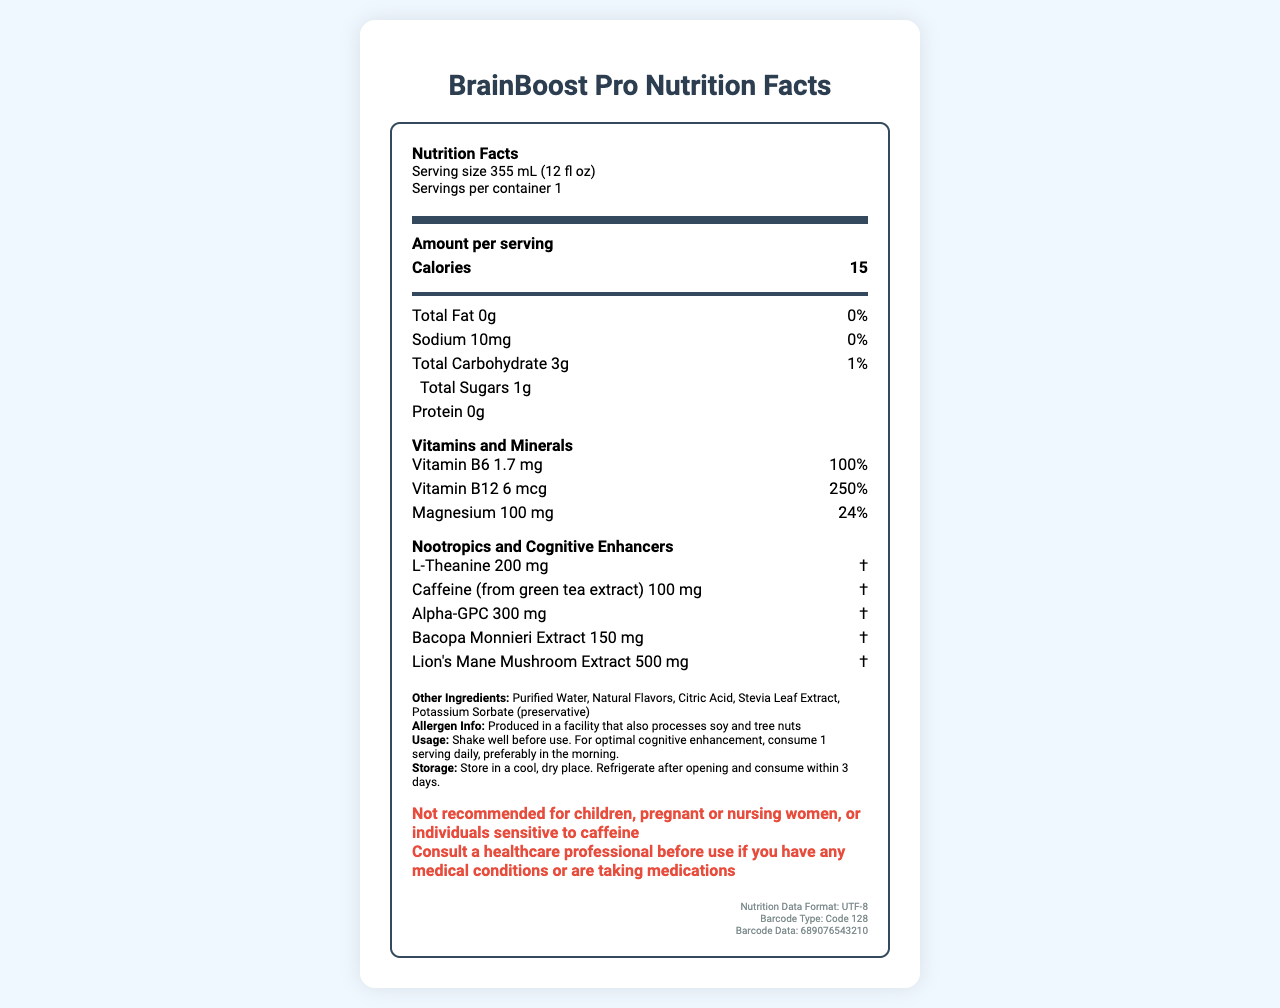What is the serving size of BrainBoost Pro? The serving size is listed directly under the "Nutrition Facts" heading in the document.
Answer: 355 mL (12 fl oz) How many calories are in one serving of BrainBoost Pro? The document shows "Calories 15" under the main nutrients section.
Answer: 15 What is the amount of sodium per serving? The sodium amount is listed as "Sodium 10mg" in the nutrients section of the document.
Answer: 10 mg How many grams of total fat does BrainBoost Pro contain? The total fat content is displayed as "Total Fat 0g" on the label.
Answer: 0 g What percentage of daily value of Vitamin B12 is provided in one serving? The document lists Vitamin B12 as having a daily value of 250%.
Answer: 250% What is the amount of Alpha-GPC in BrainBoost Pro? The amount of Alpha-GPC is listed under the section "Nootropics and Cognitive Enhancers".
Answer: 300 mg How many vitamins and minerals are listed on the nutrition facts label? The nutrition facts label shows Vitamin B6, Vitamin B12, and Magnesium.
Answer: 3 What nootropic ingredient has the highest amount in BrainBoost Pro? A. L-Theanine B. Caffeine C. Lion's Mane Mushroom Extract D. Bacopa Monnieri Extract The amount of Lion's Mane Mushroom Extract is 500 mg, which is the highest among the nootropics listed.
Answer: C Which vitamin has the highest percentage of daily value? 1. Vitamin B6 2. Vitamin B12 3. Magnesium Vitamin B12 has a daily value of 250%, higher than the other vitamins and minerals listed.
Answer: 2 Is BrainBoost Pro suitable for individuals sensitive to caffeine? The document includes a warning that it is not recommended for individuals sensitive to caffeine.
Answer: No Summarize the main nutritional information and special ingredients in BrainBoost Pro. The explanation condenses the main nutrition facts and highlights the added nootropics and cognitive enhancers in the product.
Answer: BrainBoost Pro contains 15 calories, 0g total fat, 10mg sodium, 3g total carbohydrate, and 1g total sugars per 355 mL serving. It has no protein. The beverage includes important vitamins and minerals such as Vitamin B6 (100% daily value), Vitamin B12 (250% daily value), and Magnesium (24% daily value). It also features several nootropics and cognitive enhancers like L-Theanine (200 mg), Caffeine from green tea extract (100 mg), Alpha-GPC (300 mg), Bacopa Monnieri Extract (150 mg), and Lion's Mane Mushroom Extract (500 mg). What is the barcode type used for BrainBoost Pro? The document's encoding info section specifies the barcode type as Code 128.
Answer: Code 128 Can you determine the number of carbohydrates from insoluble fiber in BrainBoost Pro? The document does not provide specific information about the amount of insoluble fiber.
Answer: Cannot be determined 